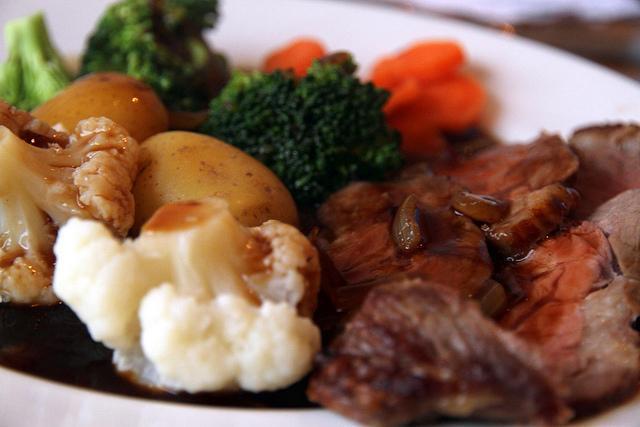How many carrots are in the photo?
Give a very brief answer. 2. 